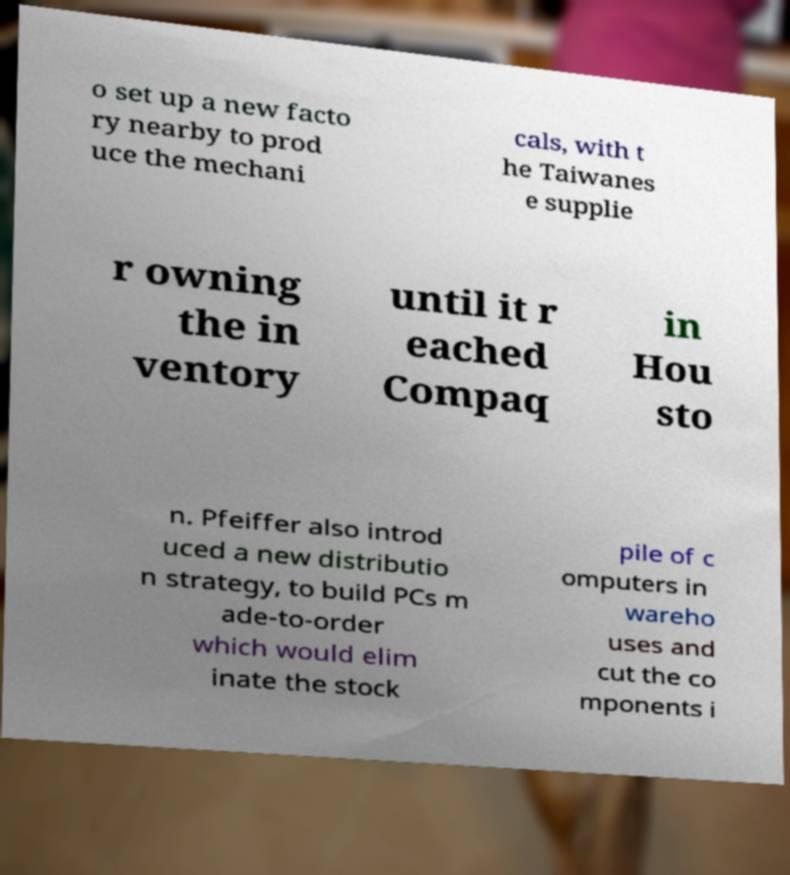Can you accurately transcribe the text from the provided image for me? o set up a new facto ry nearby to prod uce the mechani cals, with t he Taiwanes e supplie r owning the in ventory until it r eached Compaq in Hou sto n. Pfeiffer also introd uced a new distributio n strategy, to build PCs m ade-to-order which would elim inate the stock pile of c omputers in wareho uses and cut the co mponents i 